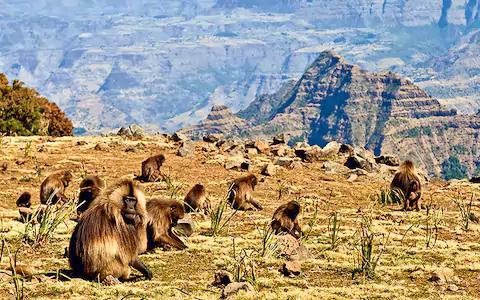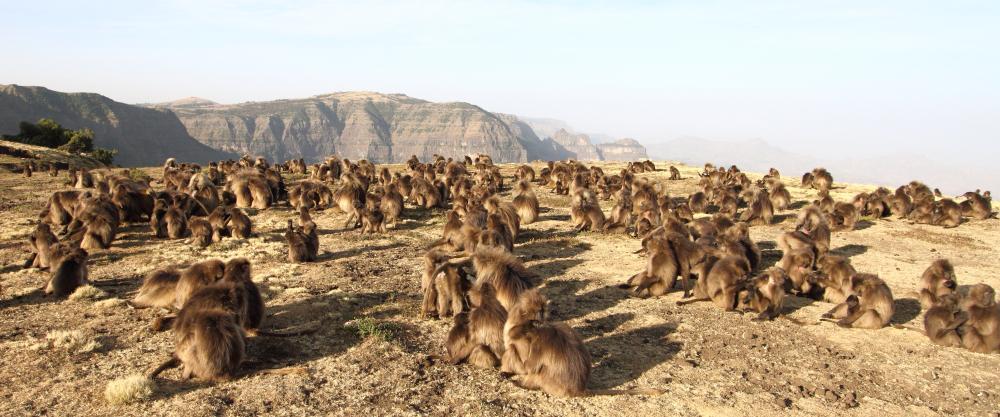The first image is the image on the left, the second image is the image on the right. For the images shown, is this caption "All images feature monkeys sitting on grass." true? Answer yes or no. No. The first image is the image on the left, the second image is the image on the right. Evaluate the accuracy of this statement regarding the images: "An image shows baboons sitting in a green valley with many visible trees on the hillside behind them.". Is it true? Answer yes or no. No. 